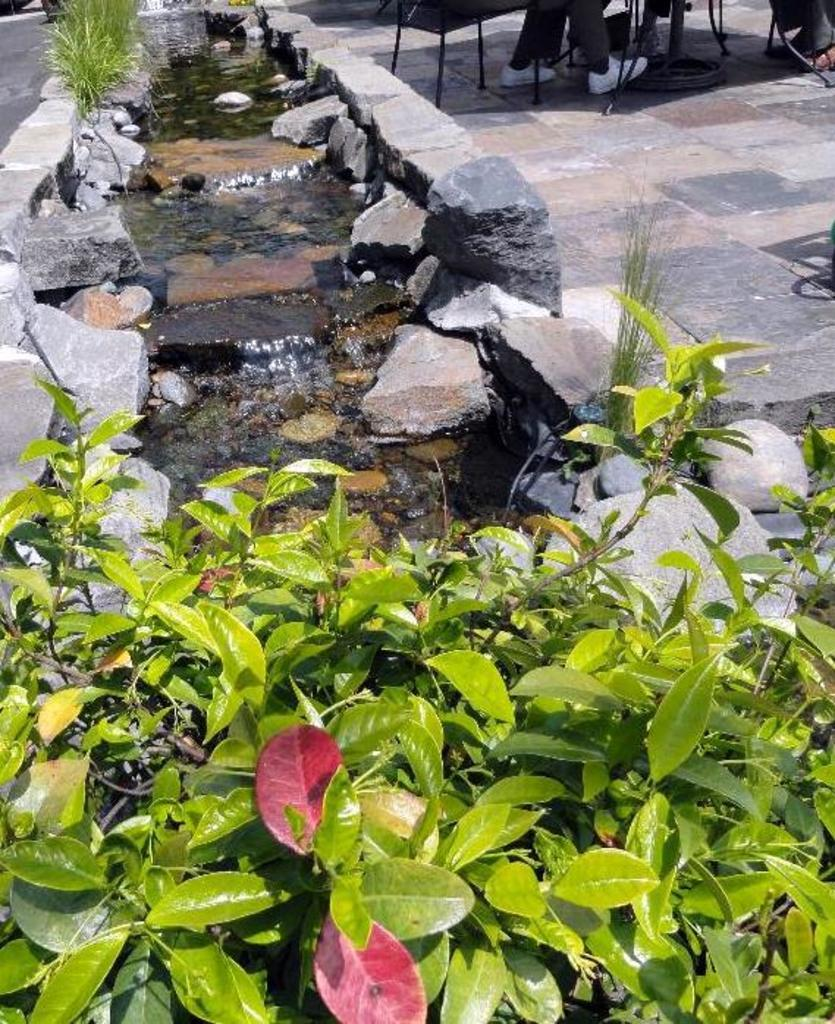What type of natural elements can be seen in the image? There are rocks, plants, and water visible in the image. Can you describe the rocks in the image? The rocks in the image are likely part of a natural landscape or terrain. What type of plants are present in the image? The plants in the image are not specified, but they are likely to be native to the environment where the image was taken. What type of stamp can be seen on the rocks in the image? There is no stamp present on the rocks in the image; they are natural elements. 